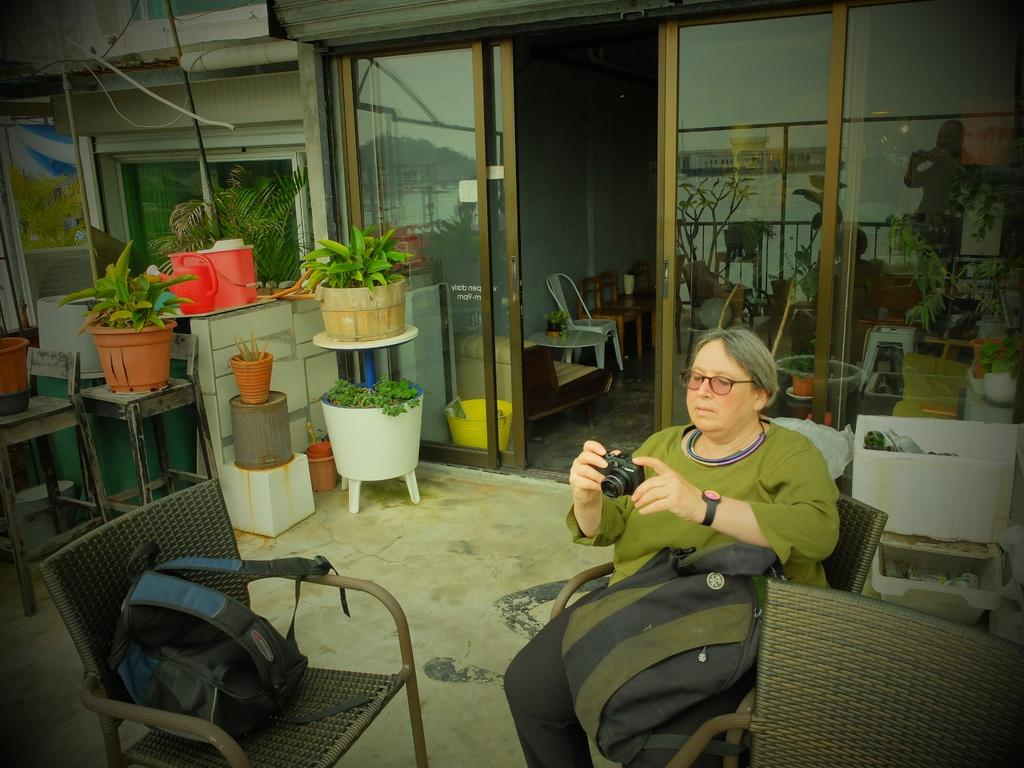Who is the main subject in the image? There is a lady in the image. What is the lady doing in the image? The lady is sitting on a chair and holding a camera. How many backpacks are visible in the image? There are two backpacks in the image. What else can be seen in the image besides the lady and backpacks? There are two additional chairs, plants on a table, and chairs around the lady. What type of vest is the lady wearing in the image? There is no vest visible in the image; the lady is wearing a camera around her neck. 